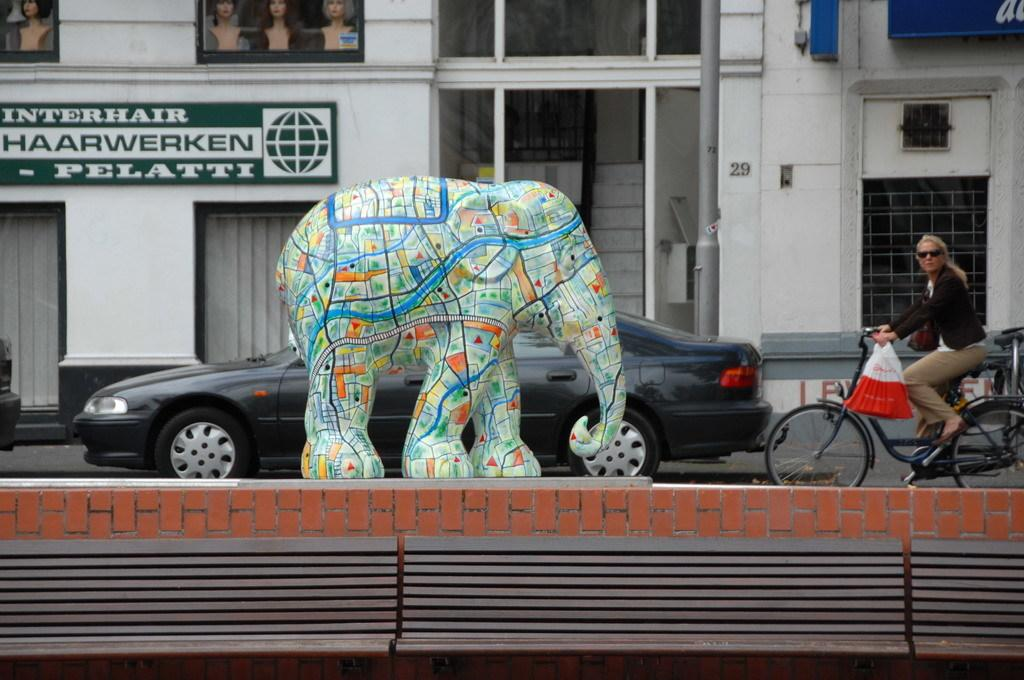What is the main subject of the image? There is an Elephant statue in the image. What is located behind the Elephant statue? There is a car behind the Elephant statue. What mode of transportation can be seen in the image? There is a bicycle in the image. Who is using the bicycle in the image? A woman is riding the bicycle. What type of powder is being used to clean the Elephant statue in the image? There is no powder visible in the image, and the Elephant statue is not being cleaned. 